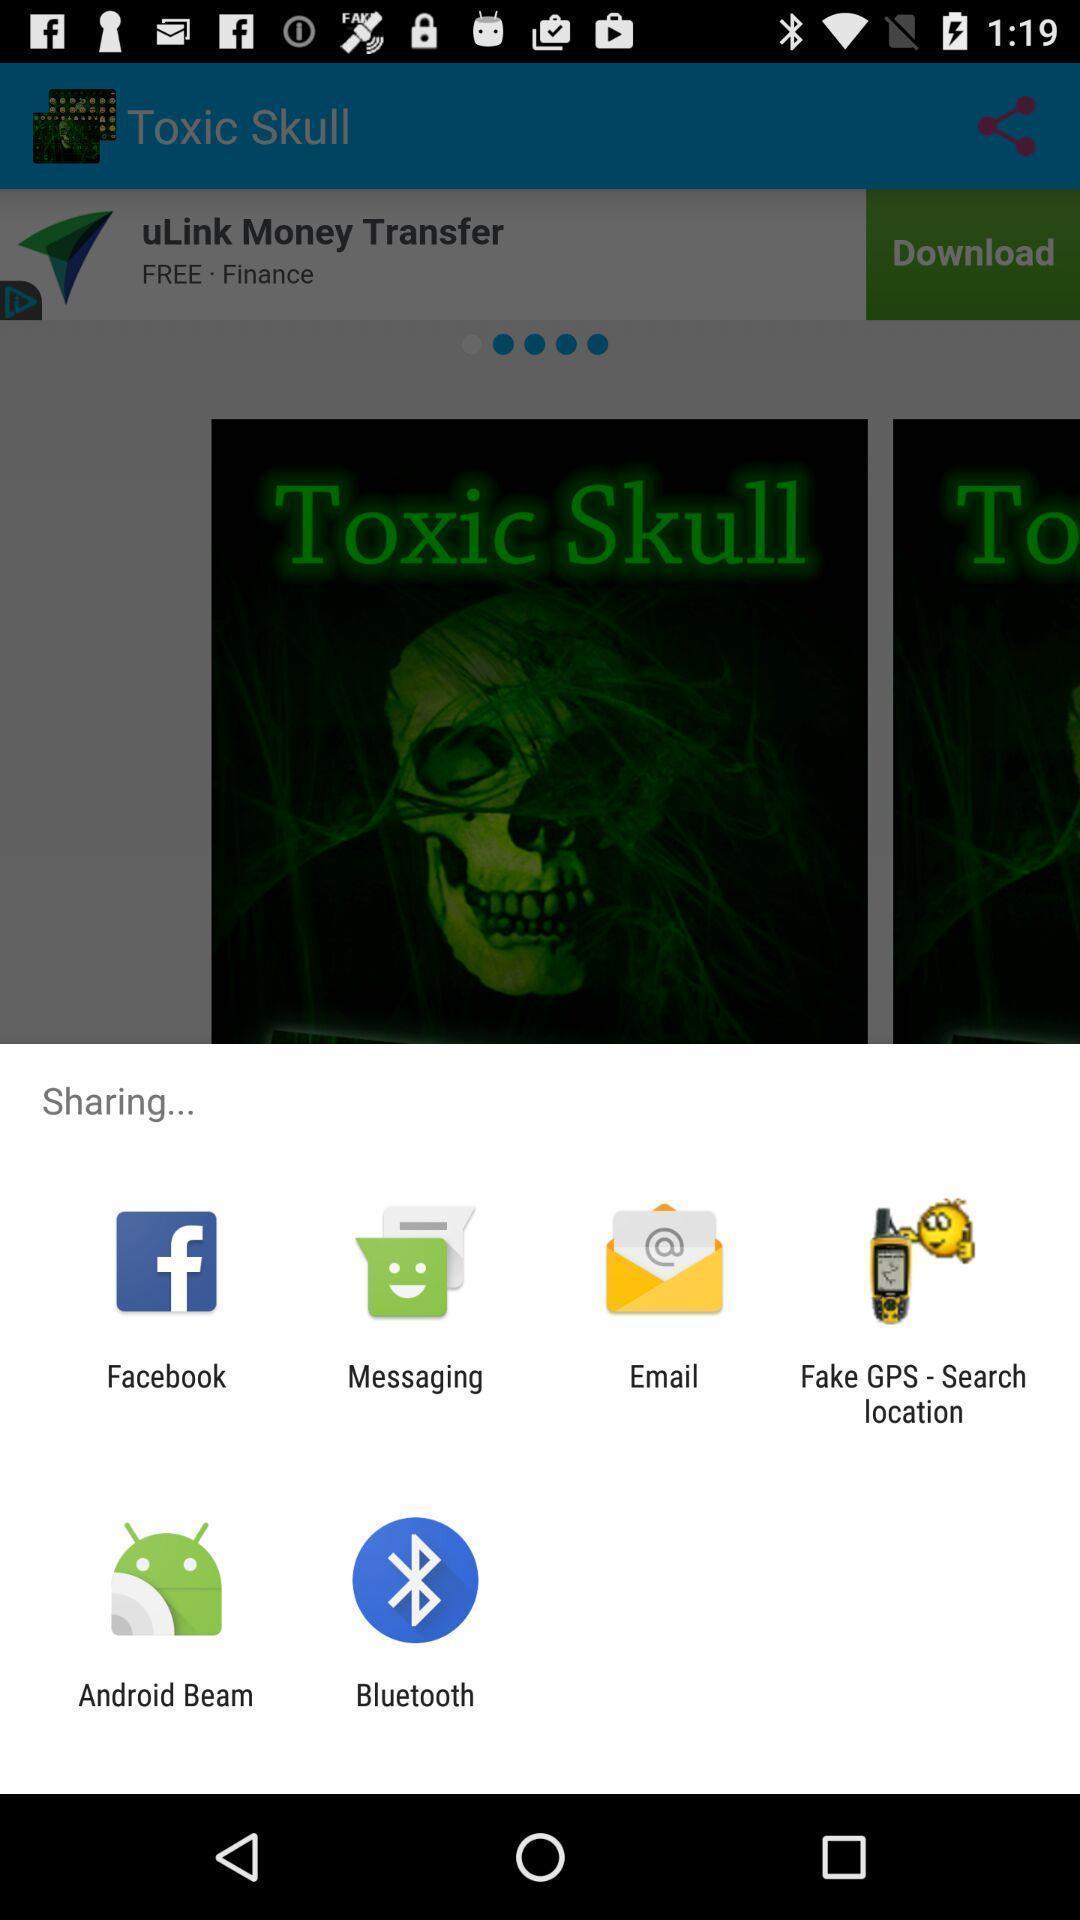Provide a textual representation of this image. Screen displaying to share using different social applications. 